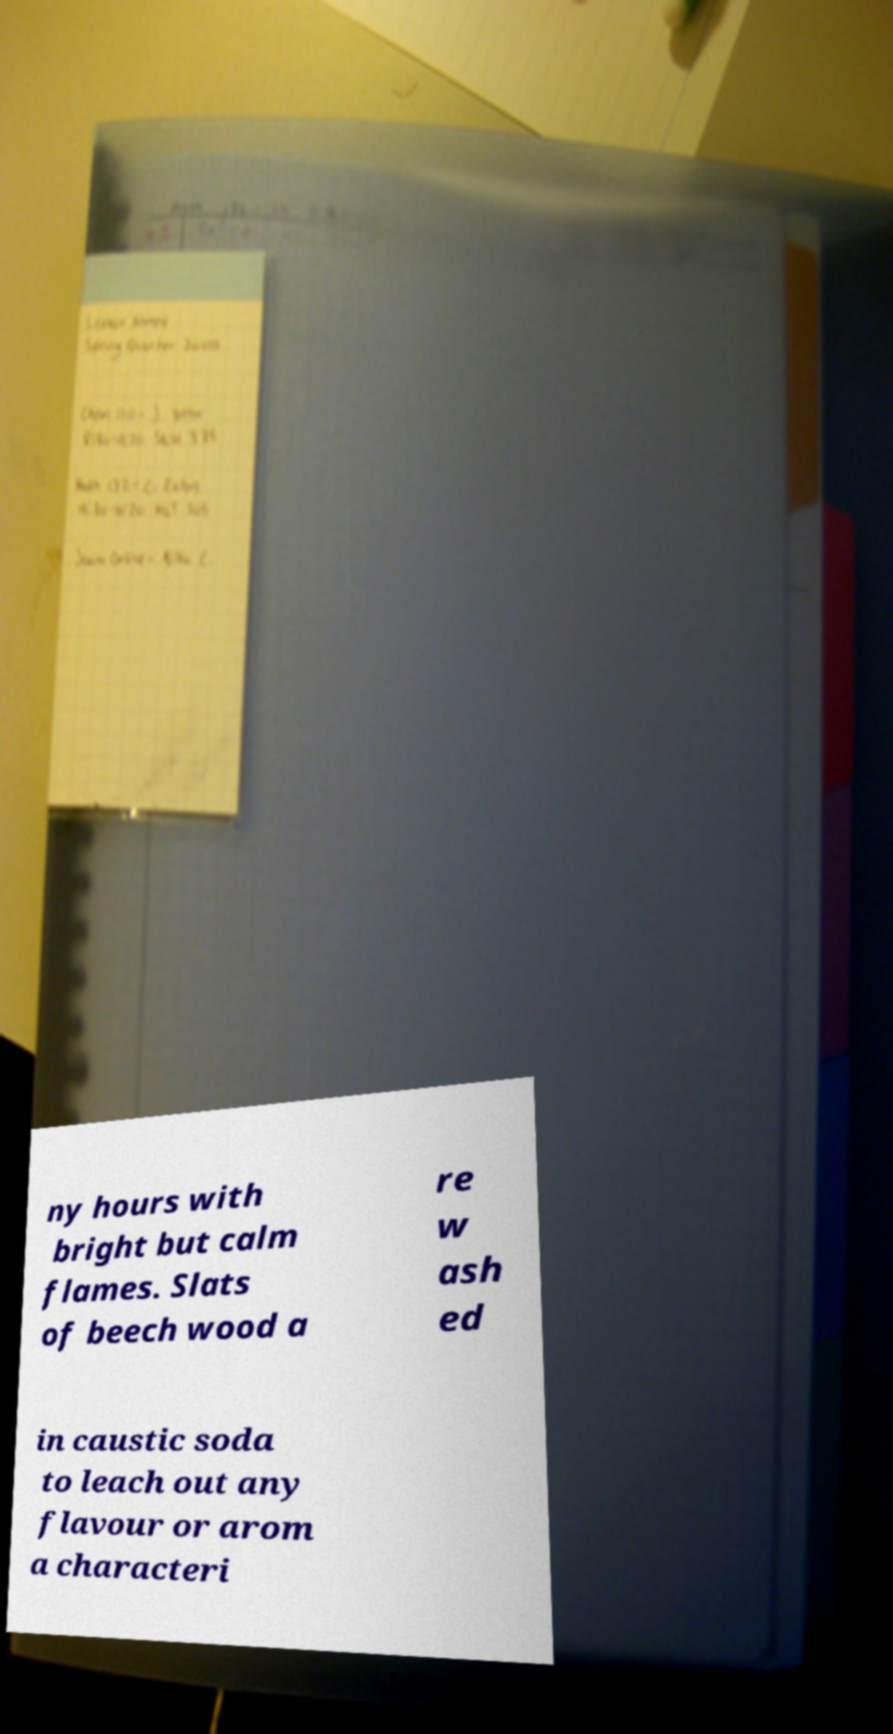I need the written content from this picture converted into text. Can you do that? ny hours with bright but calm flames. Slats of beech wood a re w ash ed in caustic soda to leach out any flavour or arom a characteri 